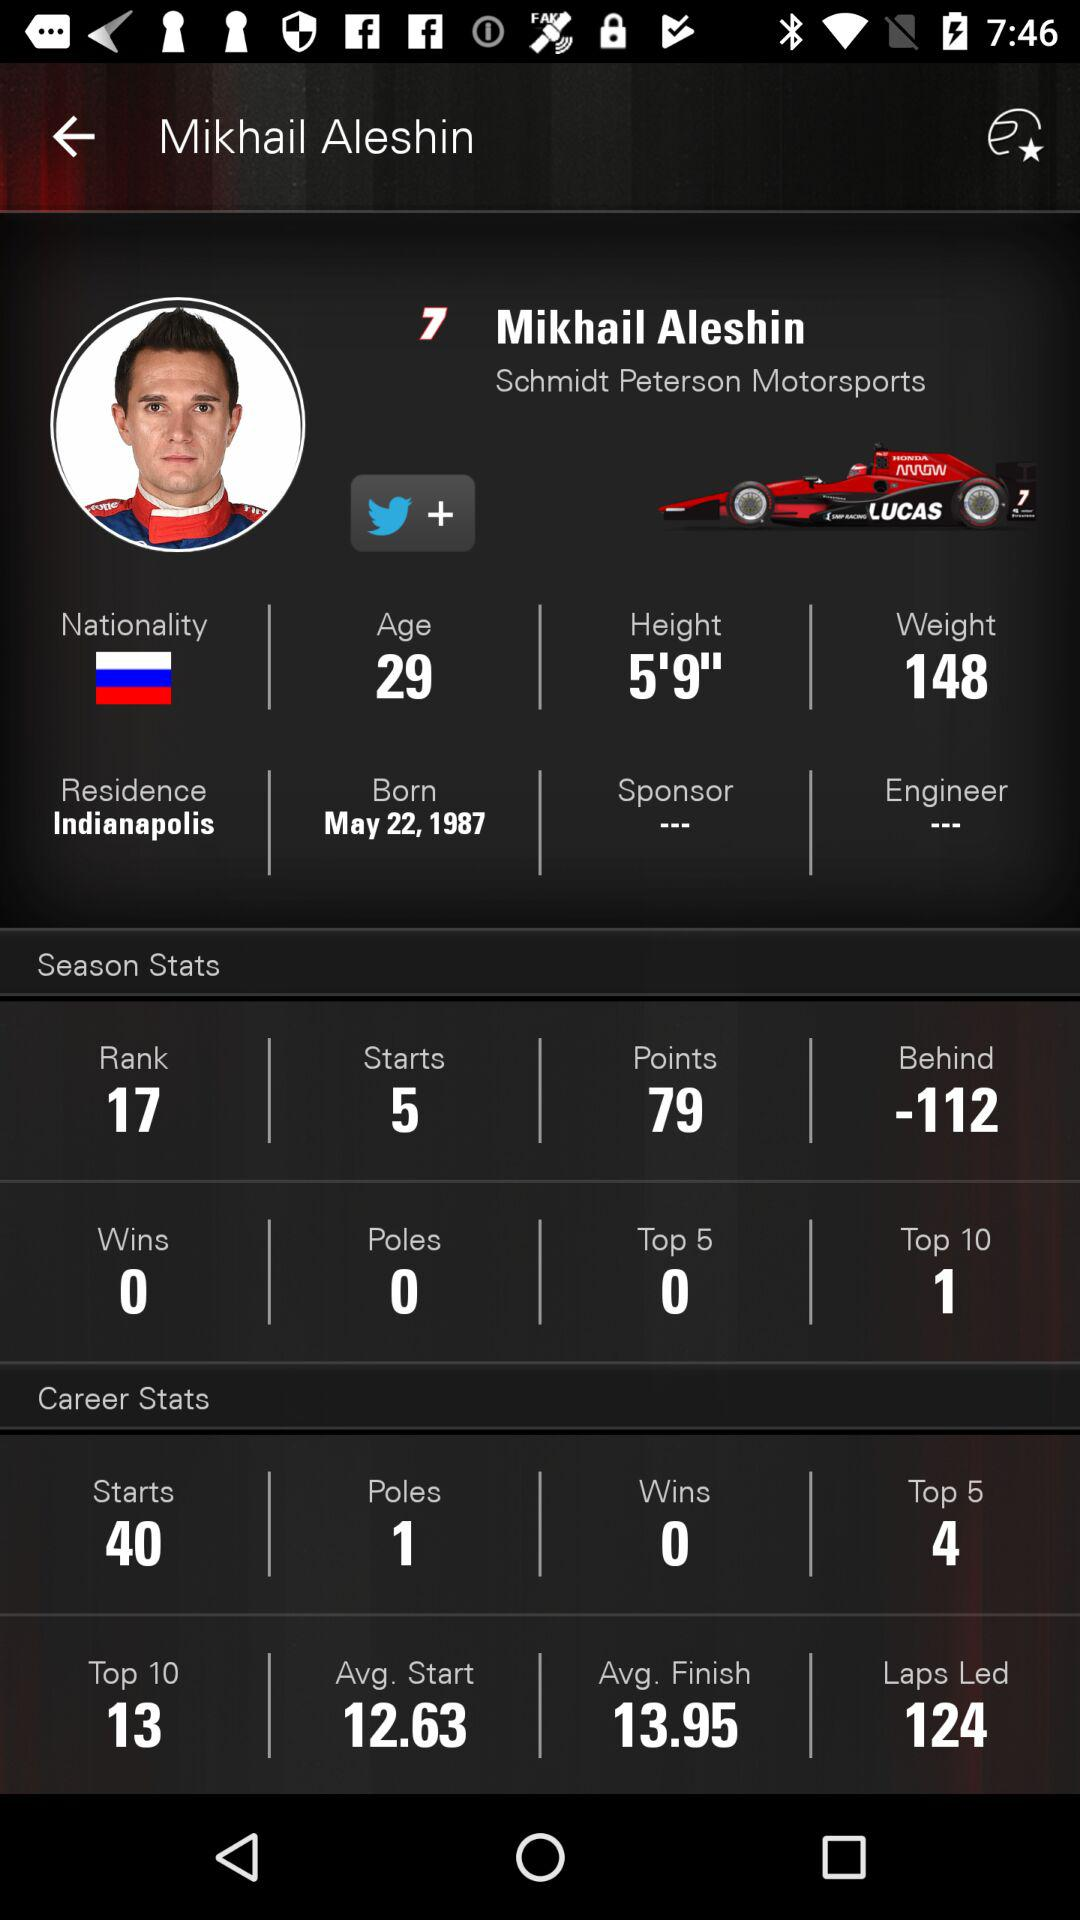What is the rank of Mikhail Aleshin? The rank of Mikhail Aleshin is 17. 